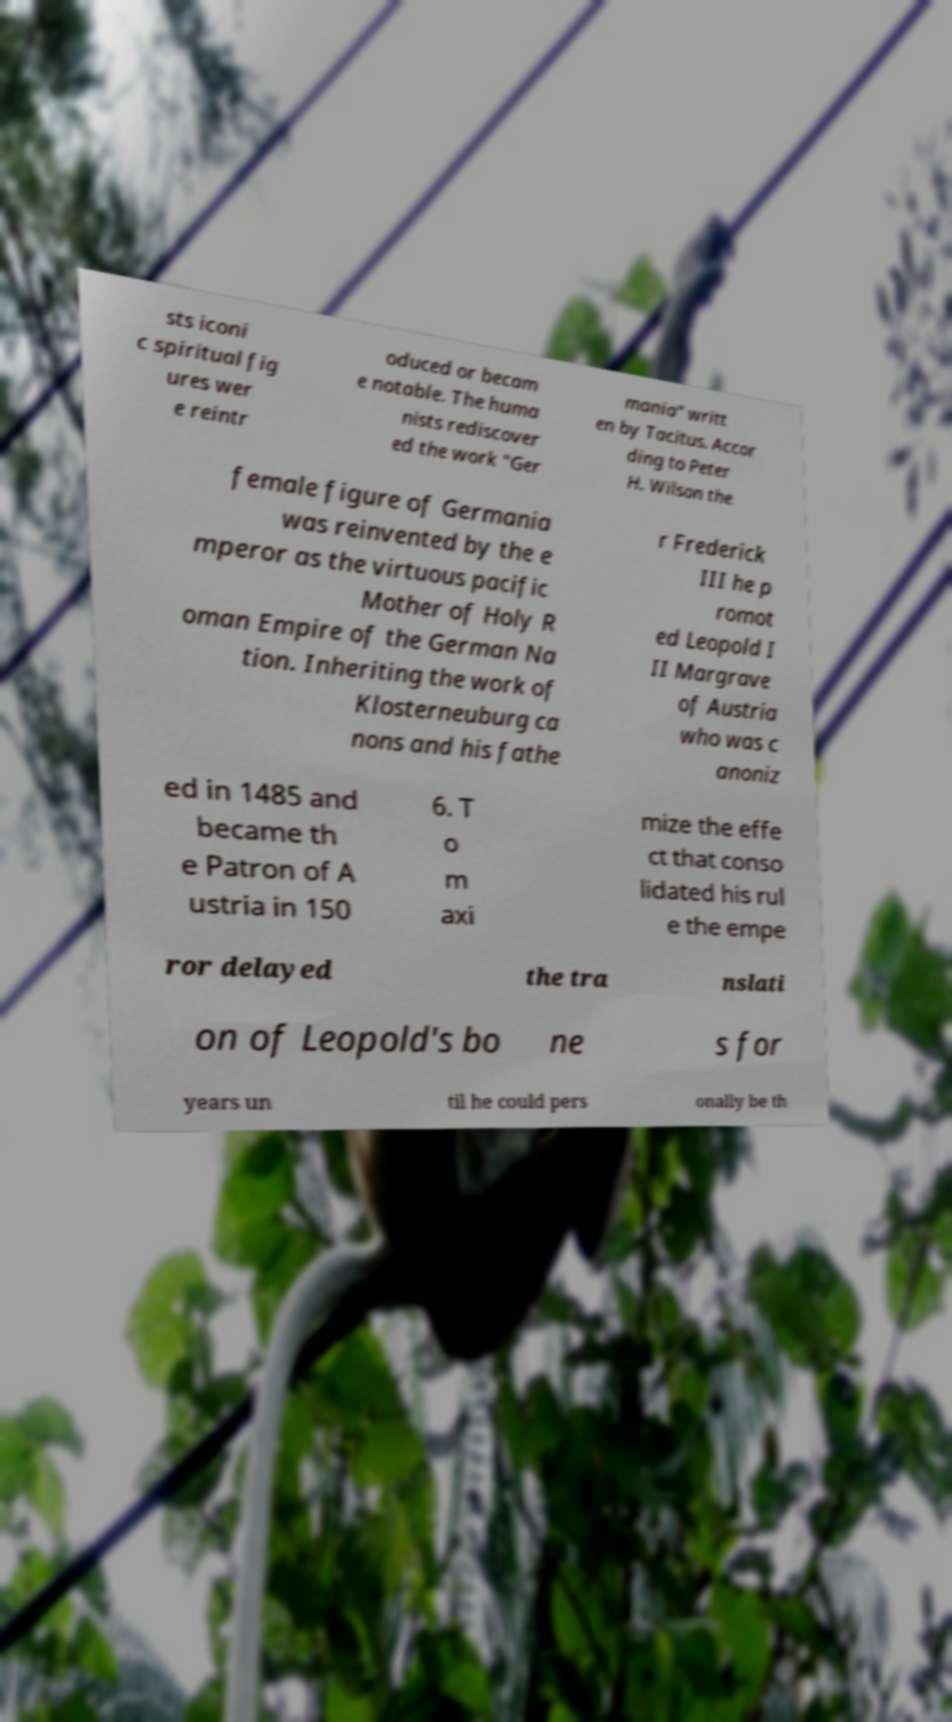What messages or text are displayed in this image? I need them in a readable, typed format. sts iconi c spiritual fig ures wer e reintr oduced or becam e notable. The huma nists rediscover ed the work "Ger mania" writt en by Tacitus. Accor ding to Peter H. Wilson the female figure of Germania was reinvented by the e mperor as the virtuous pacific Mother of Holy R oman Empire of the German Na tion. Inheriting the work of Klosterneuburg ca nons and his fathe r Frederick III he p romot ed Leopold I II Margrave of Austria who was c anoniz ed in 1485 and became th e Patron of A ustria in 150 6. T o m axi mize the effe ct that conso lidated his rul e the empe ror delayed the tra nslati on of Leopold's bo ne s for years un til he could pers onally be th 